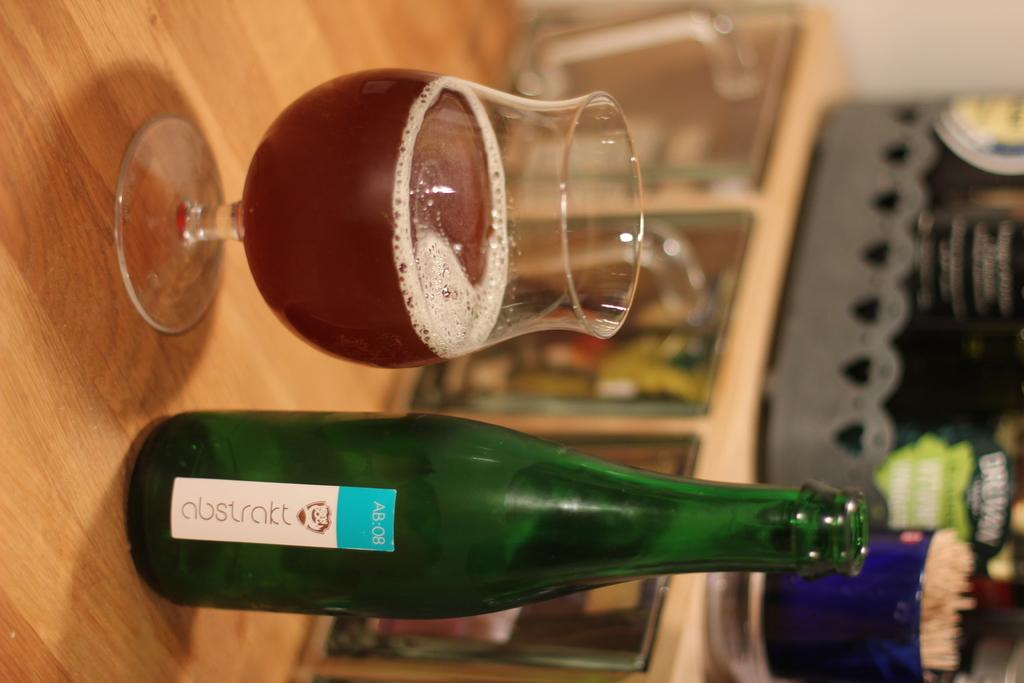<image>
Render a clear and concise summary of the photo. A bottle of Abstrakt AB:08 beer next to a glass which is half full 